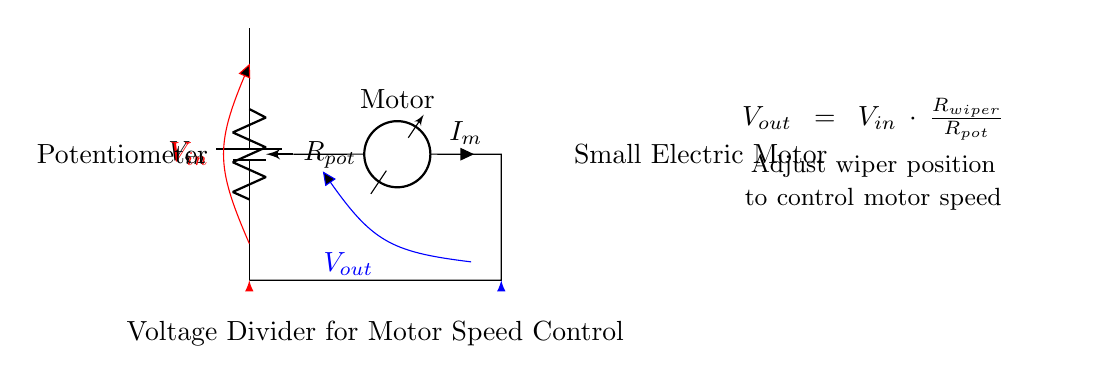What is the input voltage in this circuit? The input voltage is denoted as \(V_{in}\) and is represented by the battery symbol in the circuit diagram, indicating the source of power for the voltage divider.
Answer: \(V_{in}\) What component is used to control motor speed? The circuit uses a potentiometer, indicated as \(R_{pot}\), which adjusts the voltage output based on its wiper position, ultimately controlling the speed of the motor.
Answer: Potentiometer What is the relationship between the output voltage and the potentiometer's wiper position? The output voltage \(V_{out}\) is given by the formula \(V_{out} = V_{in} \cdot \frac{R_{wiper}}{R_{pot}}\). This means that as the wiper position changes, it alters \(R_{wiper}\), affecting \(V_{out}\), and consequently the speed of the motor.
Answer: Directly proportional How does the motor's current relate to the potential divider components? The current \(I_m\) through the motor is influenced by the output voltage \(V_{out}\) from the potentiometer, which is determined by the ratio of resistances in the voltage divider. The current flow can be calculated if these values are known.
Answer: Influenced by \(V_{out}\) What is the purpose of the wiper in the potentiometer? The wiper of the potentiometer allows adjustment of resistance \(R_{wiper}\), changing the division of voltage between \(R_{pot}\) and the wiper, which in turn affects the output voltage \(V_{out}\) used to control motor speed.
Answer: Adjust output voltage What happens to the output voltage if the potentiometer’s wiper is turned to a maximum position? If the potentiometer's wiper is turned to the maximum position, \(R_{wiper}\) will equal the total resistance \(R_{pot}\). From the formula \(V_{out} = V_{in} \cdot \frac{R_{wiper}}{R_{pot}}\), this indicates that the output voltage \(V_{out}\) will be equal to the input voltage \(V_{in}\).
Answer: Equal to \(V_{in}\) 